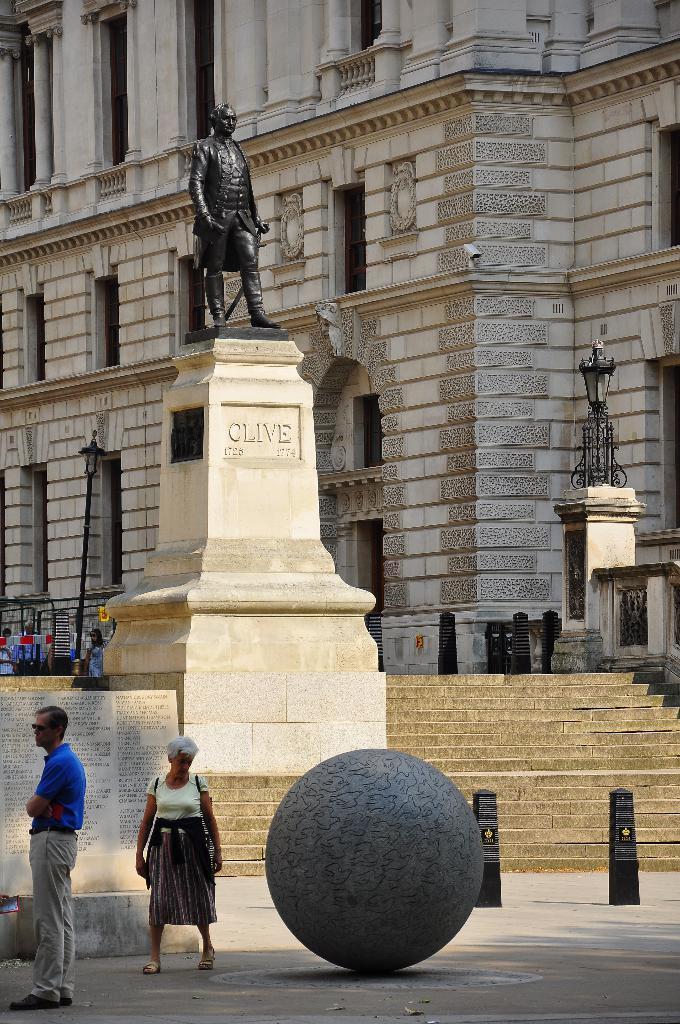In one or two sentences, can you explain what this image depicts? In this picture there is a black statue placed on the brown pillar. Behind there is a brown building with some windows. In the front bottom side there is a round ball and a woman standing beside and looking to it. 